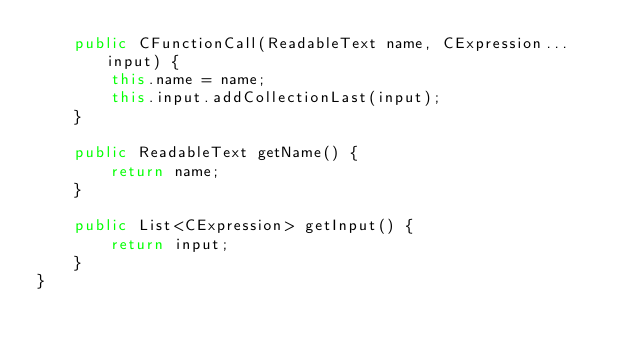Convert code to text. <code><loc_0><loc_0><loc_500><loc_500><_Java_>    public CFunctionCall(ReadableText name, CExpression... input) {
        this.name = name;
        this.input.addCollectionLast(input);
    }

    public ReadableText getName() {
        return name;
    }

    public List<CExpression> getInput() {
        return input;
    }
}
</code> 